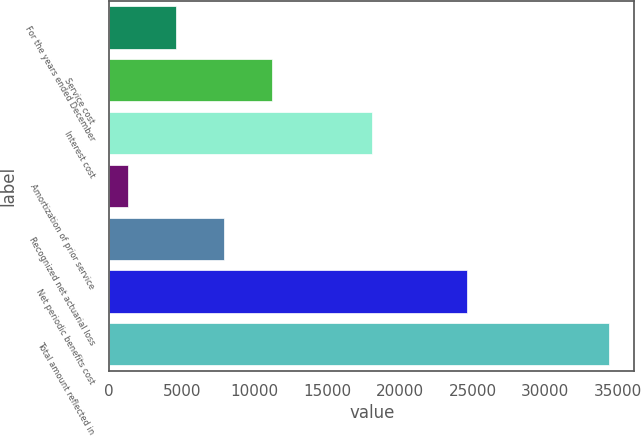<chart> <loc_0><loc_0><loc_500><loc_500><bar_chart><fcel>For the years ended December<fcel>Service cost<fcel>Interest cost<fcel>Amortization of prior service<fcel>Recognized net actuarial loss<fcel>Net periodic benefits cost<fcel>Total amount reflected in<nl><fcel>4591.9<fcel>11217.7<fcel>18115<fcel>1279<fcel>7904.8<fcel>24624<fcel>34408<nl></chart> 